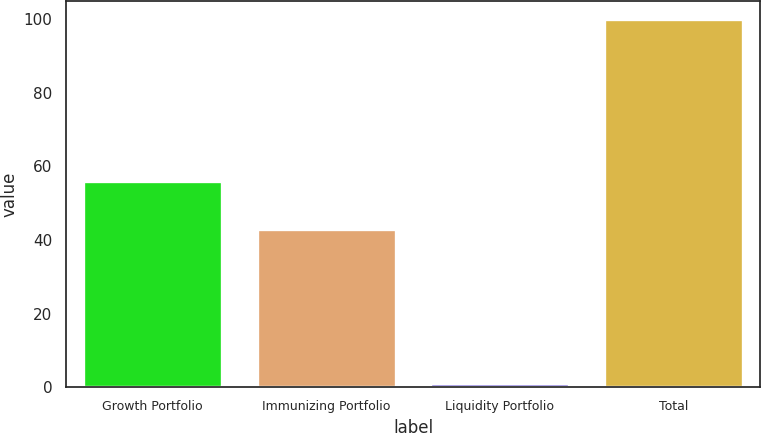Convert chart to OTSL. <chart><loc_0><loc_0><loc_500><loc_500><bar_chart><fcel>Growth Portfolio<fcel>Immunizing Portfolio<fcel>Liquidity Portfolio<fcel>Total<nl><fcel>56<fcel>43<fcel>1<fcel>100<nl></chart> 